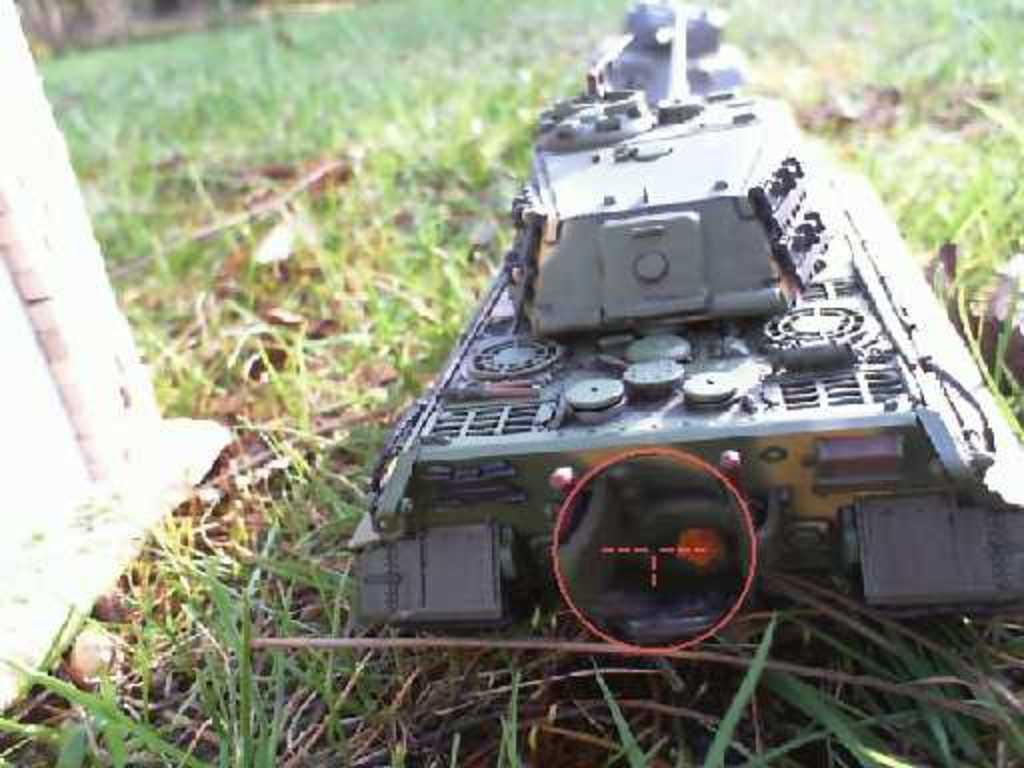What is the object on the ground covered with grass in the image? Unfortunately, the provided facts do not specify the object on the ground covered with grass. What can be seen on the left side of the image? There is a white-colored object on the left side of the image. What type of steel is visible on the dock in the image? There is no dock or steel present in the image. What is the temperature of the heat source in the image? There is no heat source present in the image. 